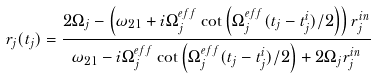Convert formula to latex. <formula><loc_0><loc_0><loc_500><loc_500>r _ { j } ( t _ { j } ) = \frac { 2 \Omega _ { j } - \left ( \omega _ { 2 1 } + i \Omega _ { j } ^ { e f f } \cot \left ( \Omega _ { j } ^ { e f f } ( t _ { j } - t _ { j } ^ { i } ) / 2 \right ) \right ) r _ { j } ^ { i n } } { \omega _ { 2 1 } - i \Omega _ { j } ^ { e f f } \cot \left ( \Omega _ { j } ^ { e f f } ( t _ { j } - t _ { j } ^ { i } ) / 2 \right ) + 2 \Omega _ { j } r _ { j } ^ { i n } }</formula> 